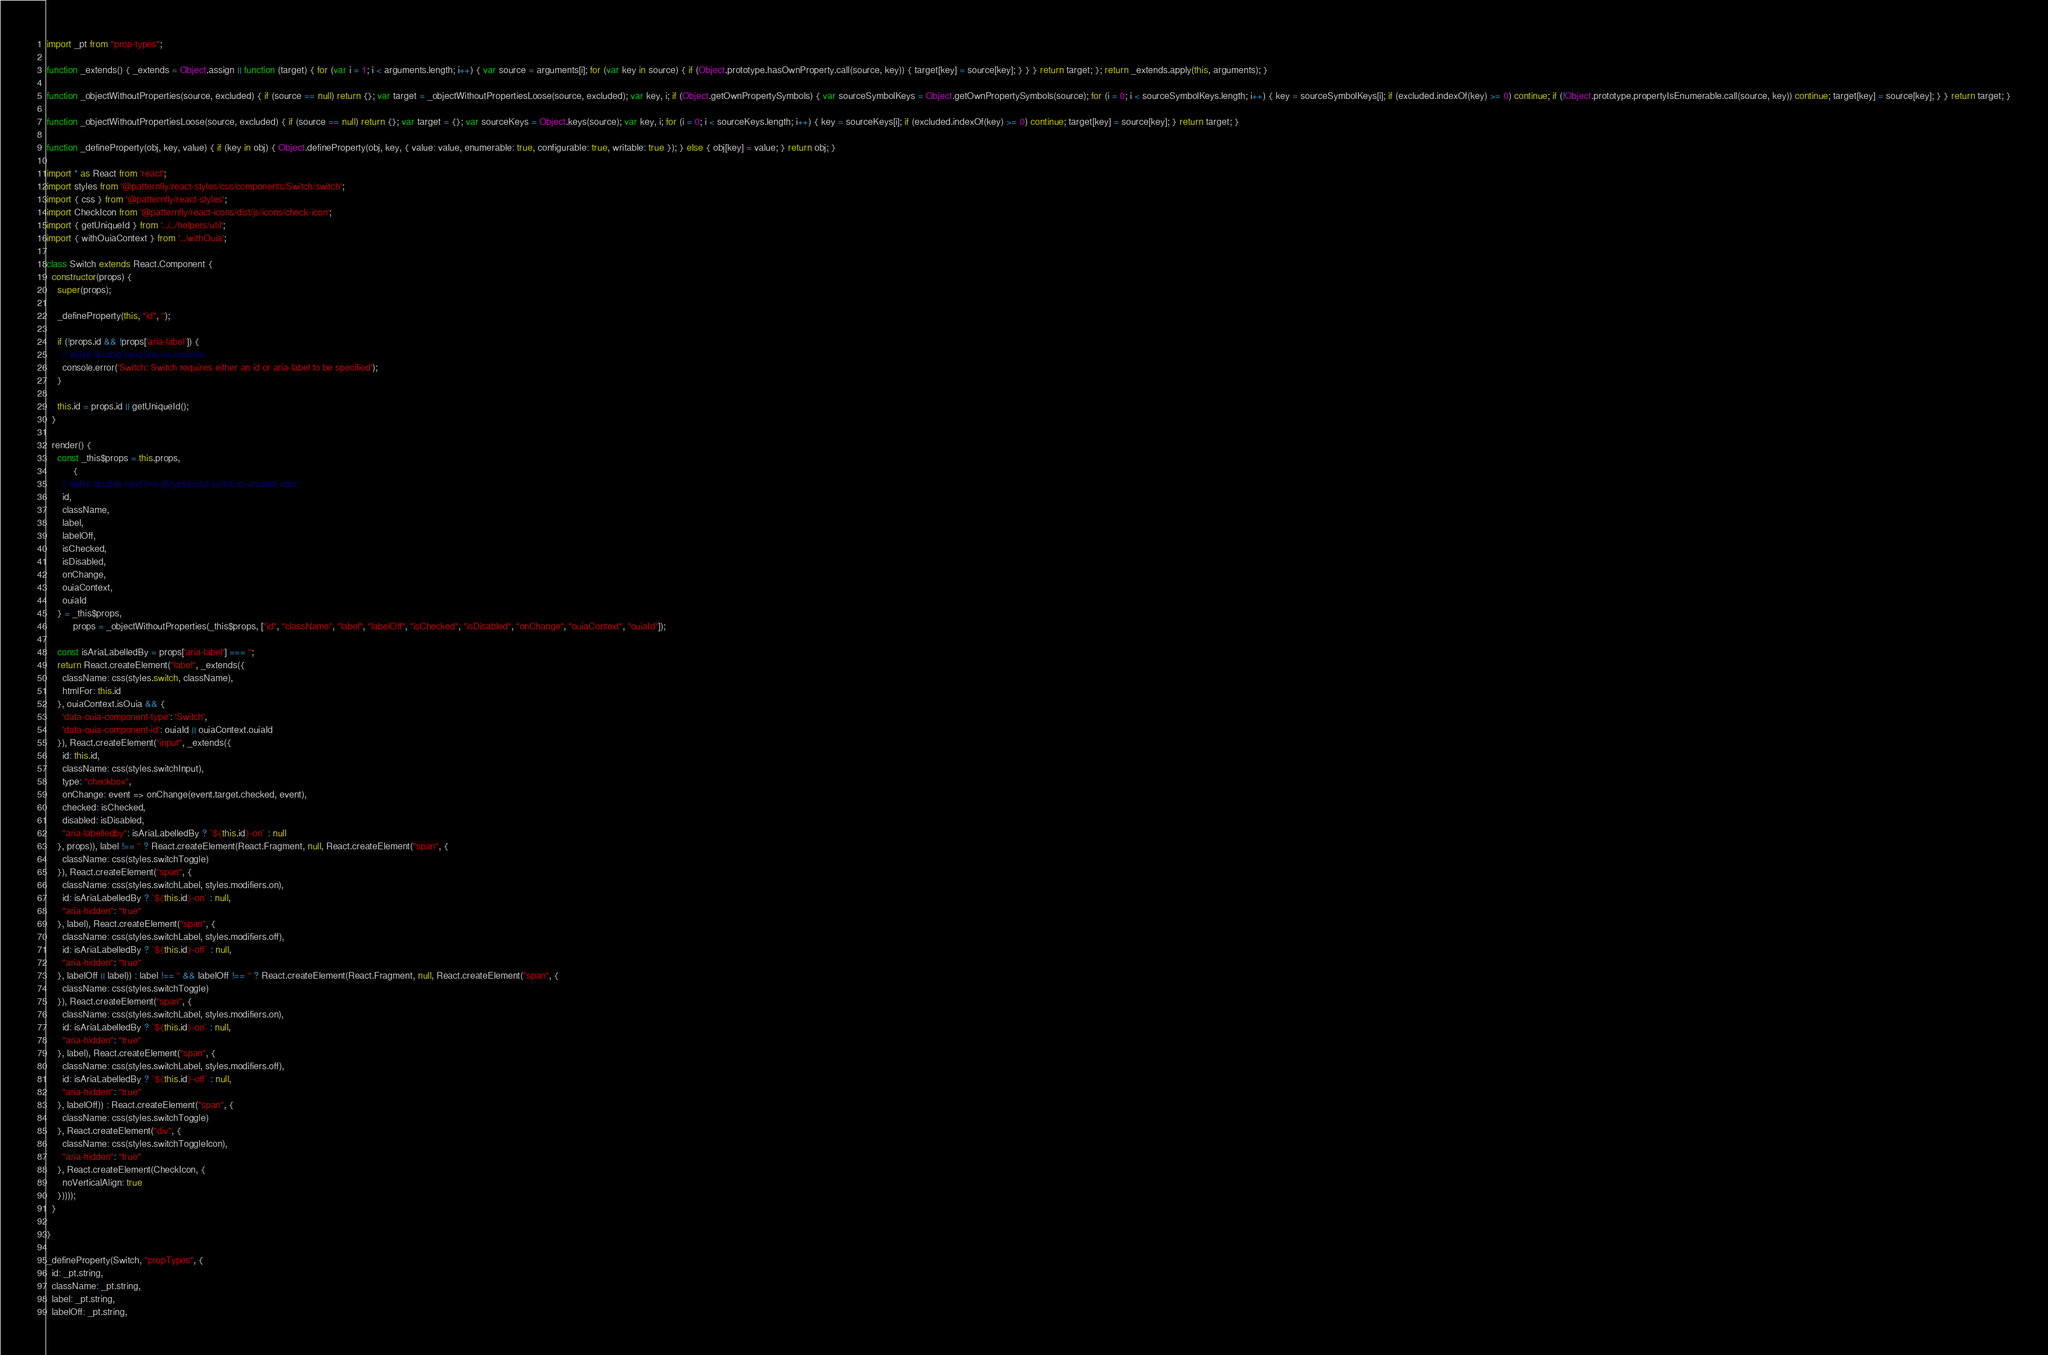<code> <loc_0><loc_0><loc_500><loc_500><_JavaScript_>import _pt from "prop-types";

function _extends() { _extends = Object.assign || function (target) { for (var i = 1; i < arguments.length; i++) { var source = arguments[i]; for (var key in source) { if (Object.prototype.hasOwnProperty.call(source, key)) { target[key] = source[key]; } } } return target; }; return _extends.apply(this, arguments); }

function _objectWithoutProperties(source, excluded) { if (source == null) return {}; var target = _objectWithoutPropertiesLoose(source, excluded); var key, i; if (Object.getOwnPropertySymbols) { var sourceSymbolKeys = Object.getOwnPropertySymbols(source); for (i = 0; i < sourceSymbolKeys.length; i++) { key = sourceSymbolKeys[i]; if (excluded.indexOf(key) >= 0) continue; if (!Object.prototype.propertyIsEnumerable.call(source, key)) continue; target[key] = source[key]; } } return target; }

function _objectWithoutPropertiesLoose(source, excluded) { if (source == null) return {}; var target = {}; var sourceKeys = Object.keys(source); var key, i; for (i = 0; i < sourceKeys.length; i++) { key = sourceKeys[i]; if (excluded.indexOf(key) >= 0) continue; target[key] = source[key]; } return target; }

function _defineProperty(obj, key, value) { if (key in obj) { Object.defineProperty(obj, key, { value: value, enumerable: true, configurable: true, writable: true }); } else { obj[key] = value; } return obj; }

import * as React from 'react';
import styles from '@patternfly/react-styles/css/components/Switch/switch';
import { css } from '@patternfly/react-styles';
import CheckIcon from '@patternfly/react-icons/dist/js/icons/check-icon';
import { getUniqueId } from '../../helpers/util';
import { withOuiaContext } from '../withOuia';

class Switch extends React.Component {
  constructor(props) {
    super(props);

    _defineProperty(this, "id", '');

    if (!props.id && !props['aria-label']) {
      // eslint-disable-next-line no-console
      console.error('Switch: Switch requires either an id or aria-label to be specified');
    }

    this.id = props.id || getUniqueId();
  }

  render() {
    const _this$props = this.props,
          {
      // eslint-disable-next-line @typescript-eslint/no-unused-vars
      id,
      className,
      label,
      labelOff,
      isChecked,
      isDisabled,
      onChange,
      ouiaContext,
      ouiaId
    } = _this$props,
          props = _objectWithoutProperties(_this$props, ["id", "className", "label", "labelOff", "isChecked", "isDisabled", "onChange", "ouiaContext", "ouiaId"]);

    const isAriaLabelledBy = props['aria-label'] === '';
    return React.createElement("label", _extends({
      className: css(styles.switch, className),
      htmlFor: this.id
    }, ouiaContext.isOuia && {
      'data-ouia-component-type': 'Switch',
      'data-ouia-component-id': ouiaId || ouiaContext.ouiaId
    }), React.createElement("input", _extends({
      id: this.id,
      className: css(styles.switchInput),
      type: "checkbox",
      onChange: event => onChange(event.target.checked, event),
      checked: isChecked,
      disabled: isDisabled,
      "aria-labelledby": isAriaLabelledBy ? `${this.id}-on` : null
    }, props)), label !== '' ? React.createElement(React.Fragment, null, React.createElement("span", {
      className: css(styles.switchToggle)
    }), React.createElement("span", {
      className: css(styles.switchLabel, styles.modifiers.on),
      id: isAriaLabelledBy ? `${this.id}-on` : null,
      "aria-hidden": "true"
    }, label), React.createElement("span", {
      className: css(styles.switchLabel, styles.modifiers.off),
      id: isAriaLabelledBy ? `${this.id}-off` : null,
      "aria-hidden": "true"
    }, labelOff || label)) : label !== '' && labelOff !== '' ? React.createElement(React.Fragment, null, React.createElement("span", {
      className: css(styles.switchToggle)
    }), React.createElement("span", {
      className: css(styles.switchLabel, styles.modifiers.on),
      id: isAriaLabelledBy ? `${this.id}-on` : null,
      "aria-hidden": "true"
    }, label), React.createElement("span", {
      className: css(styles.switchLabel, styles.modifiers.off),
      id: isAriaLabelledBy ? `${this.id}-off` : null,
      "aria-hidden": "true"
    }, labelOff)) : React.createElement("span", {
      className: css(styles.switchToggle)
    }, React.createElement("div", {
      className: css(styles.switchToggleIcon),
      "aria-hidden": "true"
    }, React.createElement(CheckIcon, {
      noVerticalAlign: true
    }))));
  }

}

_defineProperty(Switch, "propTypes", {
  id: _pt.string,
  className: _pt.string,
  label: _pt.string,
  labelOff: _pt.string,</code> 